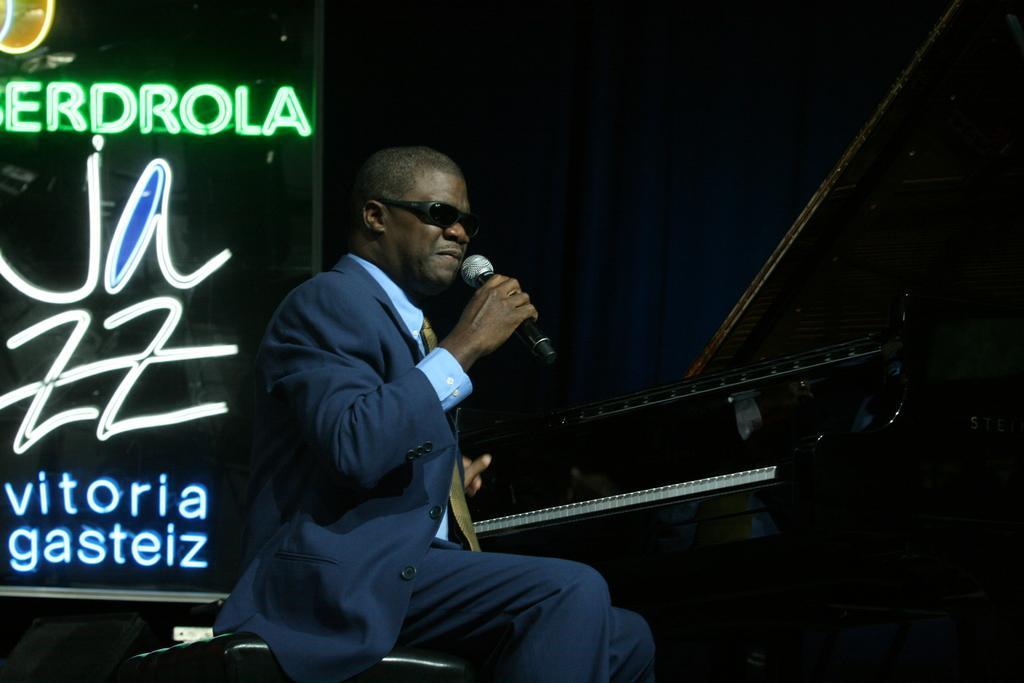In one or two sentences, can you explain what this image depicts? In this image we can see a person holding a microphone in his hand is sitting on a chair. On the right side of the image we can see a piano. On the left side of the image we can see a board with some lighting. 